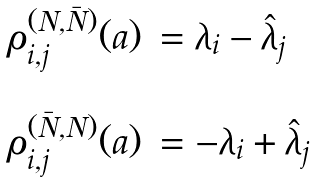<formula> <loc_0><loc_0><loc_500><loc_500>\begin{array} { l l } \rho _ { i , j } ^ { ( N , \bar { N } ) } ( a ) & = \lambda _ { i } - \hat { \lambda } _ { j } \\ \\ \rho _ { i , j } ^ { ( \bar { N } , N ) } ( a ) & = - \lambda _ { i } + \hat { \lambda } _ { j } \end{array}</formula> 